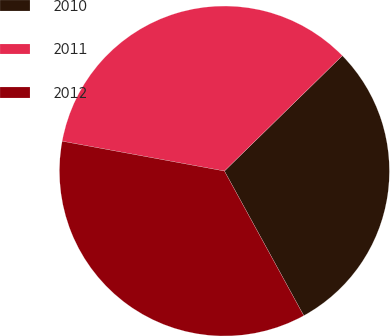<chart> <loc_0><loc_0><loc_500><loc_500><pie_chart><fcel>2010<fcel>2011<fcel>2012<nl><fcel>29.34%<fcel>34.78%<fcel>35.88%<nl></chart> 